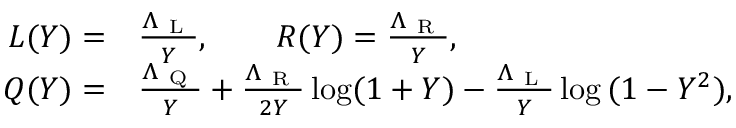Convert formula to latex. <formula><loc_0><loc_0><loc_500><loc_500>\begin{array} { r l } { L ( Y ) = } & \frac { \Lambda _ { L } } { Y } , \quad R ( Y ) = \frac { \Lambda _ { R } } { Y } , } \\ { Q ( Y ) = } & \frac { \Lambda _ { Q } } { Y } + \frac { \Lambda _ { R } } { 2 Y } \log ( 1 + Y ) - \frac { \Lambda _ { L } } { Y } \log { ( 1 - Y ^ { 2 } ) } , } \end{array}</formula> 